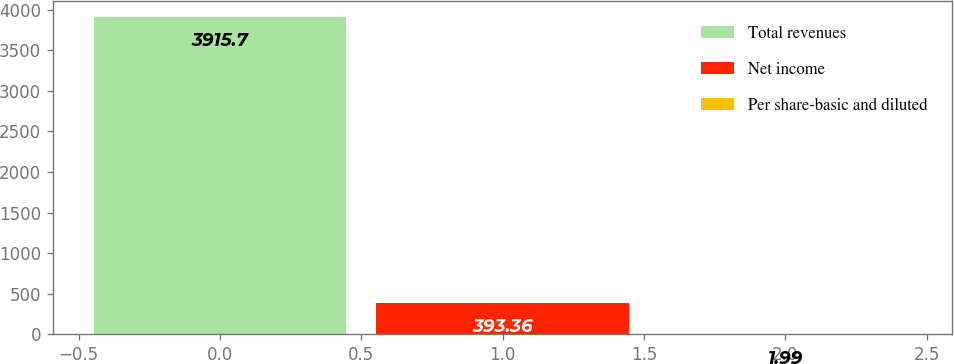Convert chart. <chart><loc_0><loc_0><loc_500><loc_500><bar_chart><fcel>Total revenues<fcel>Net income<fcel>Per share-basic and diluted<nl><fcel>3915.7<fcel>393.36<fcel>1.99<nl></chart> 